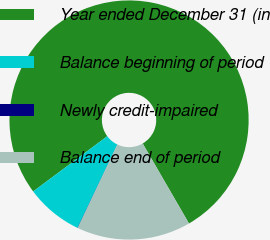Convert chart to OTSL. <chart><loc_0><loc_0><loc_500><loc_500><pie_chart><fcel>Year ended December 31 (in<fcel>Balance beginning of period<fcel>Newly credit-impaired<fcel>Balance end of period<nl><fcel>76.84%<fcel>7.72%<fcel>0.04%<fcel>15.4%<nl></chart> 